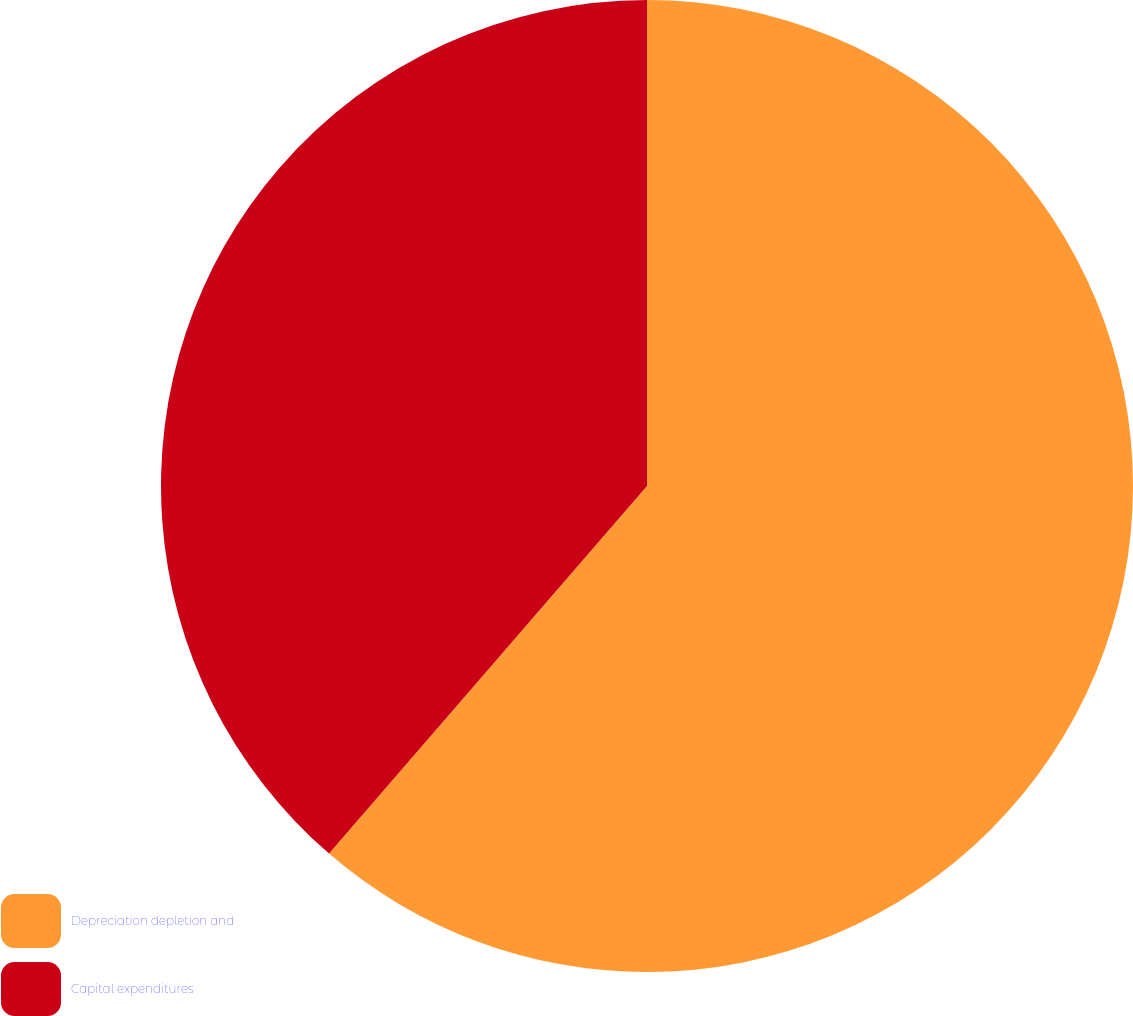<chart> <loc_0><loc_0><loc_500><loc_500><pie_chart><fcel>Depreciation depletion and<fcel>Capital expenditures<nl><fcel>61.35%<fcel>38.65%<nl></chart> 